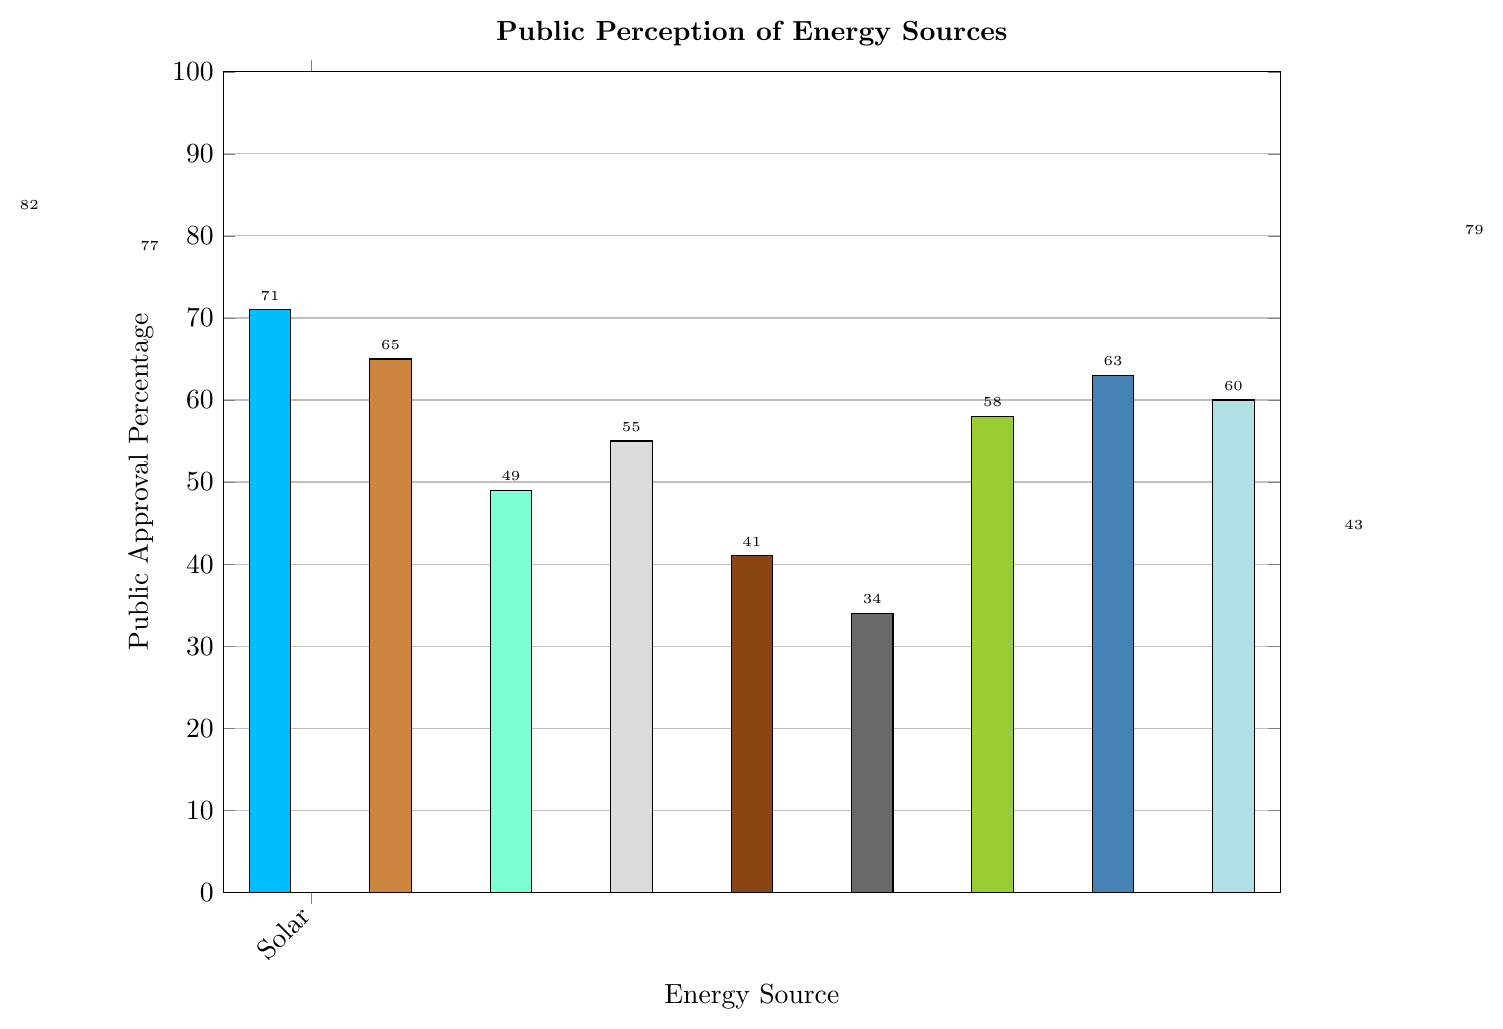What is the public approval percentage for Solar compared to Wind? Solar has a public approval percentage of 82%, and Wind has 77%. Compare these two values to see which is higher.
Answer: Solar has 5% higher approval than Wind Which energy source has the lowest public approval percentage? By looking at the bars, the shortest one corresponds to Coal. The approval percentage for Coal is given as 34%.
Answer: Coal List the renewable energy sources in descending order of public approval percentage. The renewable energy sources and their approval percentages are: Solar (82%), Wind (77%), Hydroelectric (71%), Geothermal (65%), Biomass (58%), Tidal (63%), and Hydrogen (60%). Sorting these in descending order gives: Solar, Wind, Hydroelectric, Geothermal, Tidal, Hydrogen, Biomass.
Answer: Solar, Wind, Hydroelectric, Geothermal, Tidal, Hydrogen, Biomass What is the average public approval percentage for fossil fuels (Natural Gas, Oil, and Coal)? The approval percentages for fossil fuels are Natural Gas (55%), Oil (41%), and Coal (34%). The average is calculated as (55 + 41 + 34) / 3 = 130 / 3 = 43.33%.
Answer: 43.33% What is the difference in public approval percentage between the highest-rated renewable source and the highest-rated fossil fuel source? The highest-rated renewable source is Solar with 82%, and the highest-rated fossil fuel is Natural Gas with 55%. The difference is 82 - 55 = 27%.
Answer: 27% By what percentage is the overall approval for renewables higher than the overall approval for fossil fuels? The overall approval percentage for renewables is 79%, and for fossil fuels, it is 43%. The difference is 79 - 43 = 36%.
Answer: 36% What is the median public approval percentage for the energy sources listed? The percentages to consider are: 82, 77, 71, 65, 55, 49, 41, 34, 58, 63, and 60. Ordering them: 34, 41, 49, 55, 58, 60, 63, 65, 71, 77, 82. The median value, being the 6th number in this ordered list, is 60%.
Answer: 60% Which two energy sources have equal public approval percentages, if any? By looking at the data, no two energy sources share the same public approval percentage exactly.
Answer: None What color represents Hydrogen in the chart? Locate the bar corresponding to Hydrogen; it is light blue in color.
Answer: Light blue 